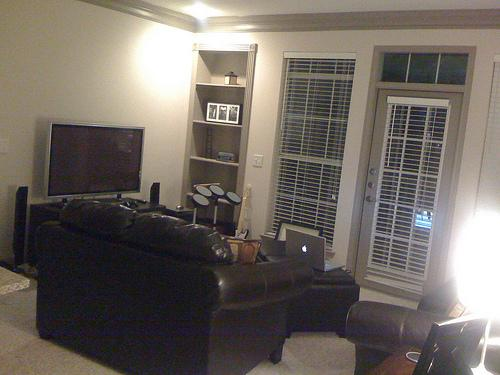Identify the type of furniture present in the room. There is a loveseat, a couch, an ottoman, a TV stand, and built-in shelving in the room. State the objects on the shelves and the end table in the room. There is a picture frame with three pictures on the shelf and another picture sitting on the end table. Mention any electronic devices in the image and where they are placed. There are a laptop computer on the ottoman, a large flat screen TV on a stand, and a set of digital drums in the room. What are the activities that one could perform in this room? One could watch TV, use a laptop, relax on the loveseat, play digital drums, and enjoy the view through the windows. In a poetic manner, describe the objects in the room. In a room of leisure and relaxation, a black leather loveseat invites repose; an open Apple laptop awaits work or play; melodies may dance from digital drums; and stories flicker on a widescreen display. List any musical instruments or audio equipment in the room. There is a guitar against the wall and speakers on either side of the TV. Describe any distinct brand featured in the image. The laptop in the image is an Apple brand laptop. Using descriptive language, describe the windows in the room. The room features long windows adorned with white blinds, situated beside a door with glass panes and mini blinds, as well as three small windows above the door. Mention any notable details related to the walls in the room. The walls have light switches, a window, built-in shelving, and a guitar leaning against them. Describe any objects or details related to the door. The door has a glass pane design and features mini blinds, a door handle, and two locks. Additionally, there are three small windows above it. 